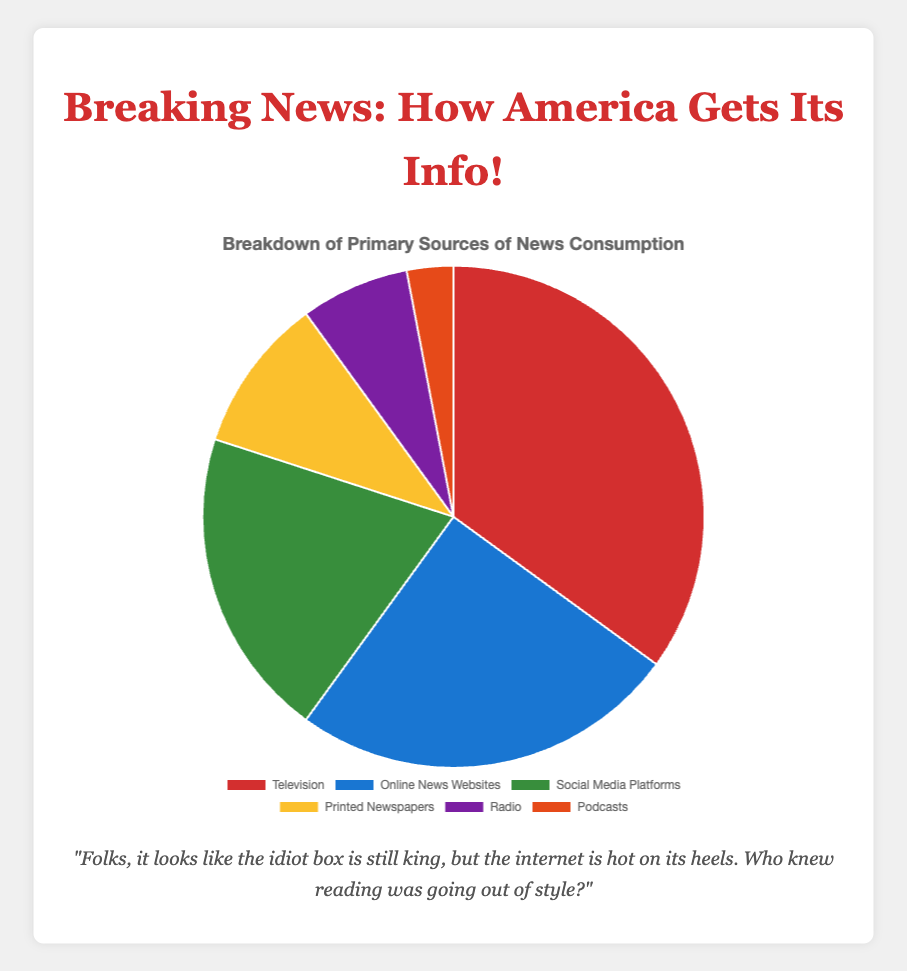What is the most popular primary source of news consumption? The figure shows that Television has the largest slice of the pie at 35%.
Answer: Television What is the combined percentage of people who get their news from Online News Websites and Social Media Platforms? The figure shows Online News Websites at 25% and Social Media Platforms at 20%. Adding these together gives 25% + 20% = 45%.
Answer: 45% Which source of news consumption has the smallest percentage? The figure shows the smallest slice of the pie for Podcasts at 3%.
Answer: Podcasts How much more popular is Television compared to Printed Newspapers? The figure indicates Television at 35% and Printed Newspapers at 10%. The difference is 35% - 10% = 25%.
Answer: 25% What is the total percentage that does not come from online sources (Online News Websites and Social Media Platforms)? The figure shows Online News Websites at 25% and Social Media Platforms at 20%. The combined percentage of online sources is 25% + 20% = 45%, so the non-online sources account for 100% - 45% = 55%.
Answer: 55% Rank the sources of news consumption from highest to lowest percentage. Referencing the figure: Television (35%), Online News Websites (25%), Social Media Platforms (20%), Printed Newspapers (10%), Radio (7%), Podcasts (3%).
Answer: Television, Online News Websites, Social Media Platforms, Printed Newspapers, Radio, Podcasts What is the color of the section representing Online News Websites in the pie chart? The figure uses a blue segment to represent Online News Websites.
Answer: Blue How much larger is the percentage of news consumption from Television compared to Radio and Podcasts combined? Television is at 35%. Radio is 7% and Podcasts are 3%. Combined, Radio and Podcasts are 7% + 3% = 10%. The difference is 35% - 10% = 25%.
Answer: 25% If Social Media Platforms and Printed Newspapers combined percentages were doubled, which source would be the highest? Social Media Platforms are at 20% and Printed Newspapers are at 10%. Doubling these percentages gives (20% * 2) + (10% * 2) = 40% + 20% = 60%, which is higher than Television at 35%.
Answer: Social Media Platforms and Printed Newspapers combined Which sources together make up more than half of the news consumption? From the figure, Television at 35% and Online News Websites at 25% together make 35% + 25% = 60%, which is more than half.
Answer: Television and Online News Websites 